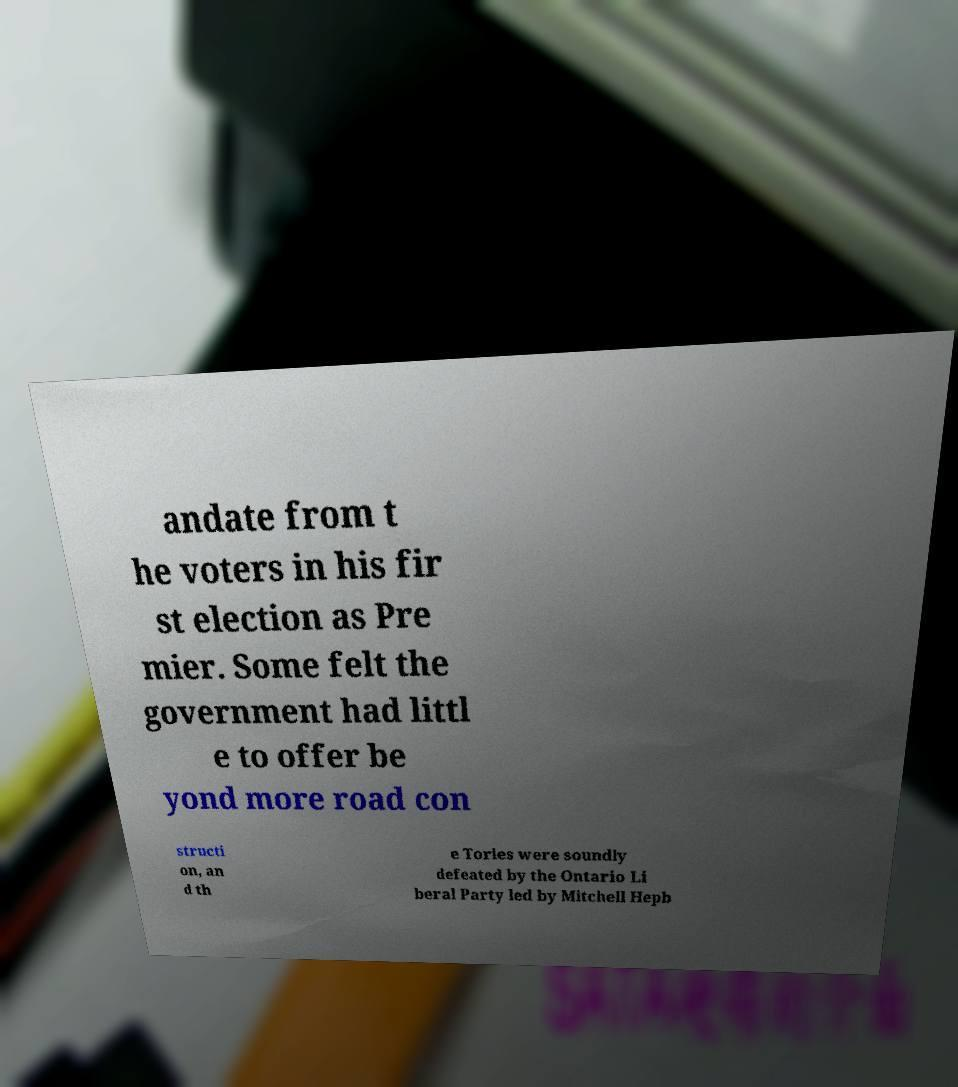Could you assist in decoding the text presented in this image and type it out clearly? andate from t he voters in his fir st election as Pre mier. Some felt the government had littl e to offer be yond more road con structi on, an d th e Tories were soundly defeated by the Ontario Li beral Party led by Mitchell Hepb 